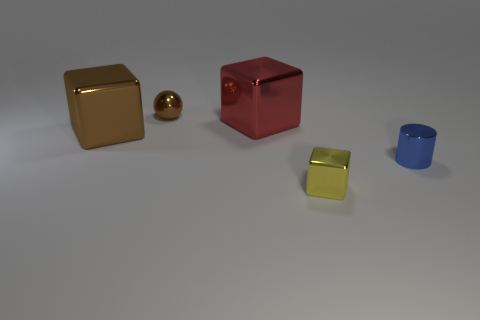Subtract all tiny blocks. How many blocks are left? 2 Subtract all yellow cubes. How many cubes are left? 2 Subtract all cylinders. How many objects are left? 4 Subtract 2 blocks. How many blocks are left? 1 Add 4 small matte balls. How many small matte balls exist? 4 Add 1 large purple rubber balls. How many objects exist? 6 Subtract 0 cyan cubes. How many objects are left? 5 Subtract all yellow balls. Subtract all purple cylinders. How many balls are left? 1 Subtract all gray cylinders. How many gray cubes are left? 0 Subtract all yellow metal blocks. Subtract all brown things. How many objects are left? 2 